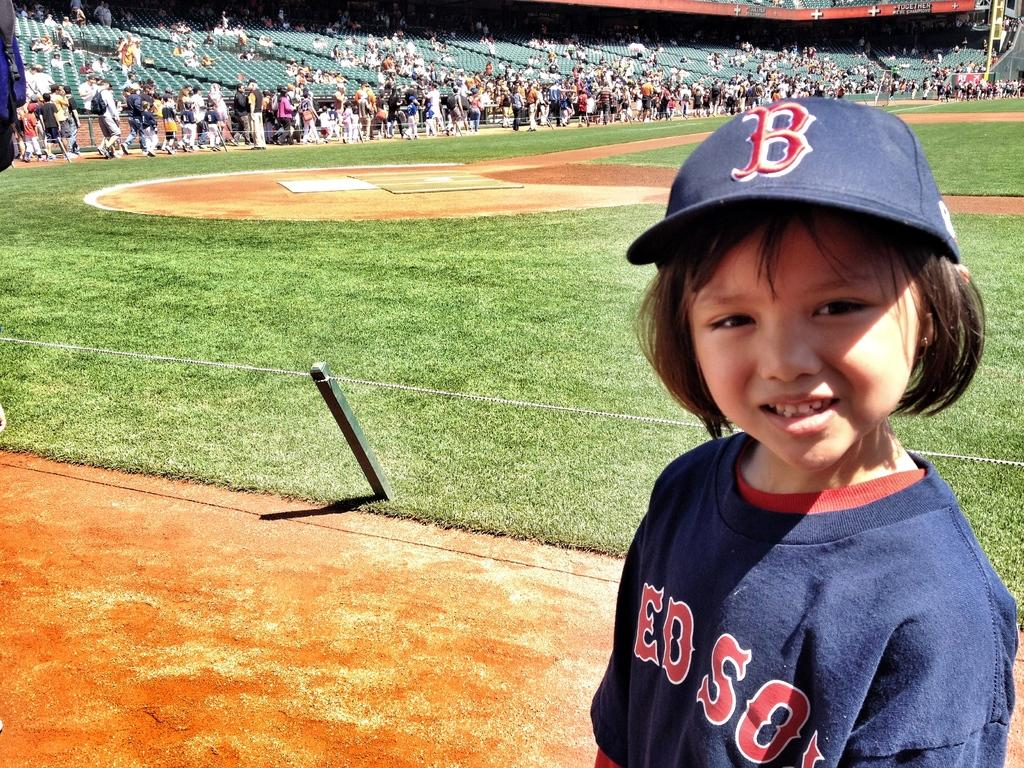<image>
Relay a brief, clear account of the picture shown. A child is photographed standing next to a baseball field wearing a blue hat with a red embroidered "B" on it. 